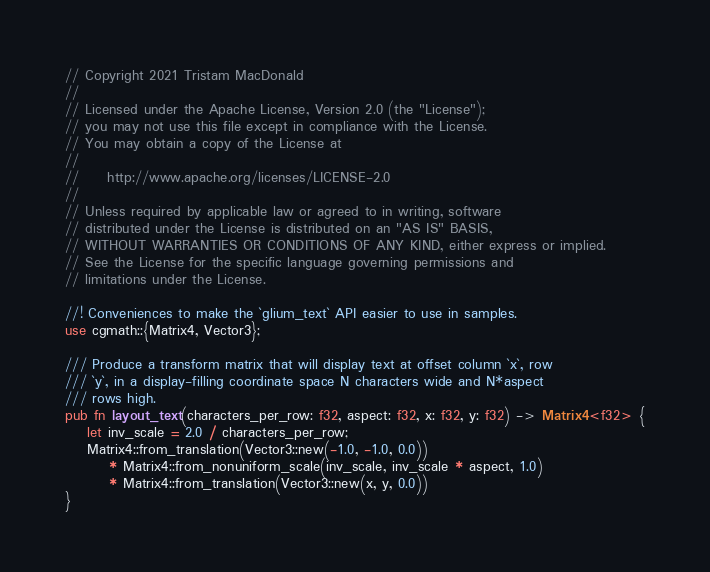<code> <loc_0><loc_0><loc_500><loc_500><_Rust_>// Copyright 2021 Tristam MacDonald
//
// Licensed under the Apache License, Version 2.0 (the "License");
// you may not use this file except in compliance with the License.
// You may obtain a copy of the License at
//
//     http://www.apache.org/licenses/LICENSE-2.0
//
// Unless required by applicable law or agreed to in writing, software
// distributed under the License is distributed on an "AS IS" BASIS,
// WITHOUT WARRANTIES OR CONDITIONS OF ANY KIND, either express or implied.
// See the License for the specific language governing permissions and
// limitations under the License.

//! Conveniences to make the `glium_text` API easier to use in samples.
use cgmath::{Matrix4, Vector3};

/// Produce a transform matrix that will display text at offset column `x`, row
/// `y`, in a display-filling coordinate space N characters wide and N*aspect
/// rows high.
pub fn layout_text(characters_per_row: f32, aspect: f32, x: f32, y: f32) -> Matrix4<f32> {
    let inv_scale = 2.0 / characters_per_row;
    Matrix4::from_translation(Vector3::new(-1.0, -1.0, 0.0))
        * Matrix4::from_nonuniform_scale(inv_scale, inv_scale * aspect, 1.0)
        * Matrix4::from_translation(Vector3::new(x, y, 0.0))
}
</code> 